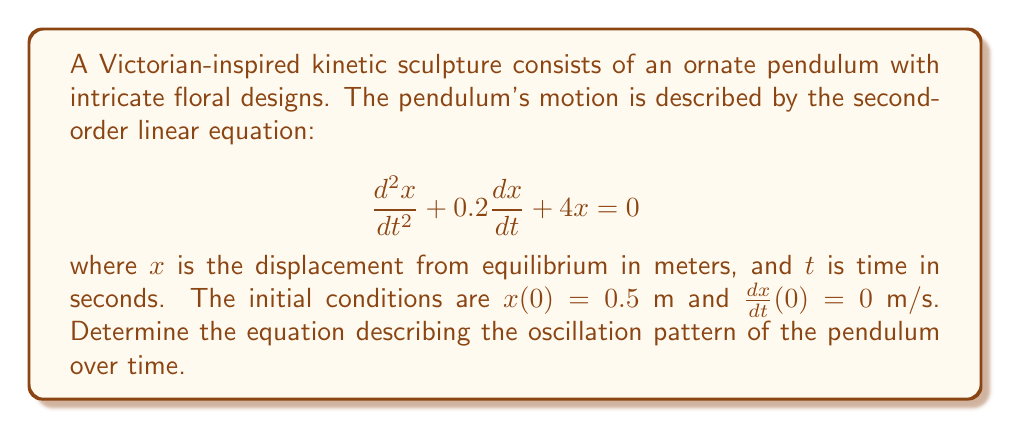Give your solution to this math problem. To solve this second-order linear equation, we follow these steps:

1) The characteristic equation for this differential equation is:
   $$r^2 + 0.2r + 4 = 0$$

2) Solving this quadratic equation:
   $$r = \frac{-0.2 \pm \sqrt{0.2^2 - 4(1)(4)}}{2(1)} = \frac{-0.2 \pm \sqrt{-15.96}}{2}$$

3) This gives us complex roots:
   $$r = -0.1 \pm 1.998i$$

4) The general solution for this underdamped system is:
   $$x(t) = e^{-0.1t}(A\cos(1.998t) + B\sin(1.998t))$$

5) To find A and B, we use the initial conditions:
   $x(0) = 0.5$ gives us $A = 0.5$
   $\frac{dx}{dt}(0) = 0$ gives us $B = 0.05$

6) Therefore, the specific solution is:
   $$x(t) = e^{-0.1t}(0.5\cos(1.998t) + 0.05\sin(1.998t))$$

This equation describes an underdamped oscillation, where the amplitude decreases exponentially over time due to the damping factor, while the pendulum continues to oscillate with a frequency of approximately 1.998 rad/s.
Answer: $$x(t) = e^{-0.1t}(0.5\cos(1.998t) + 0.05\sin(1.998t))$$ 